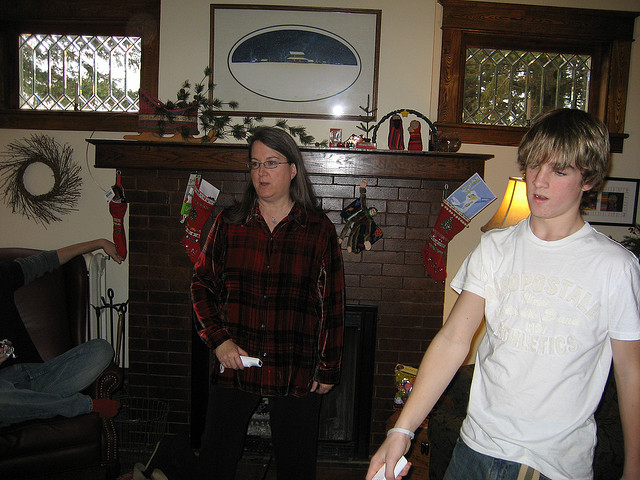<image>What are the people's emotions? It is ambiguous to determine the people's emotions. They could be feeling a range of emotions such as neutral, shocked, interested, happy, sad, bored, intense, or annoyed. What is the brand of the contraption on the left? I am not sure about the brand of the contraption on the left. It might be Nintendo or Dell. What creature is depicted on the woman's sweater? I don't know what creature is depicted on the woman's sweater. It could possibly be a horse, a man, a dragon, a snake, or none at all. What are the people's emotions? It is ambiguous what are the people's emotions. It can be seen 'neutral', 'shocked', 'interested', 'happy', 'sad', 'bored', 'intense', or 'annoyed'. What is the brand of the contraption on the left? I don't know the brand of the contraption on the left. It can be seen as 'nintendo', 'nintendo wii', 'dell', or 'wii'. What creature is depicted on the woman's sweater? It is ambiguous what creature is depicted on the woman's sweater. It can be seen as horse, man, dragon, snake or no creature, just plaid. 